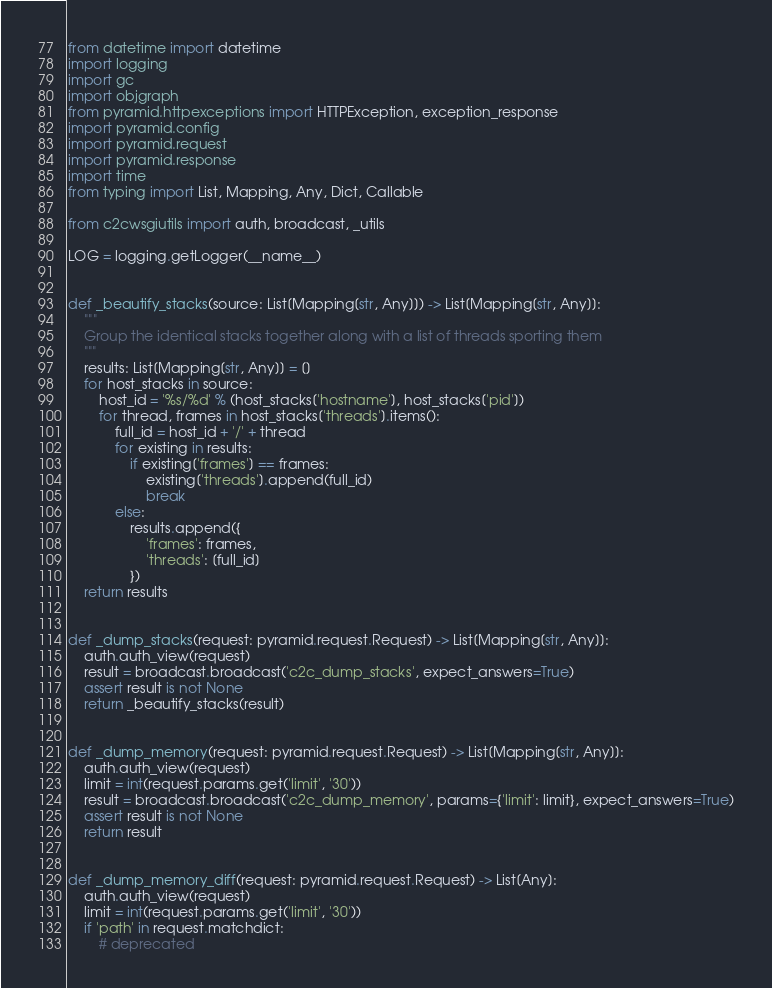Convert code to text. <code><loc_0><loc_0><loc_500><loc_500><_Python_>from datetime import datetime
import logging
import gc
import objgraph
from pyramid.httpexceptions import HTTPException, exception_response
import pyramid.config
import pyramid.request
import pyramid.response
import time
from typing import List, Mapping, Any, Dict, Callable

from c2cwsgiutils import auth, broadcast, _utils

LOG = logging.getLogger(__name__)


def _beautify_stacks(source: List[Mapping[str, Any]]) -> List[Mapping[str, Any]]:
    """
    Group the identical stacks together along with a list of threads sporting them
    """
    results: List[Mapping[str, Any]] = []
    for host_stacks in source:
        host_id = '%s/%d' % (host_stacks['hostname'], host_stacks['pid'])
        for thread, frames in host_stacks['threads'].items():
            full_id = host_id + '/' + thread
            for existing in results:
                if existing['frames'] == frames:
                    existing['threads'].append(full_id)
                    break
            else:
                results.append({
                    'frames': frames,
                    'threads': [full_id]
                })
    return results


def _dump_stacks(request: pyramid.request.Request) -> List[Mapping[str, Any]]:
    auth.auth_view(request)
    result = broadcast.broadcast('c2c_dump_stacks', expect_answers=True)
    assert result is not None
    return _beautify_stacks(result)


def _dump_memory(request: pyramid.request.Request) -> List[Mapping[str, Any]]:
    auth.auth_view(request)
    limit = int(request.params.get('limit', '30'))
    result = broadcast.broadcast('c2c_dump_memory', params={'limit': limit}, expect_answers=True)
    assert result is not None
    return result


def _dump_memory_diff(request: pyramid.request.Request) -> List[Any]:
    auth.auth_view(request)
    limit = int(request.params.get('limit', '30'))
    if 'path' in request.matchdict:
        # deprecated</code> 